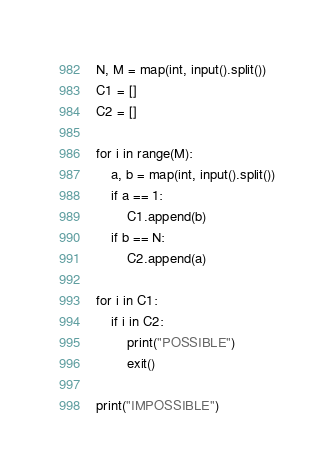<code> <loc_0><loc_0><loc_500><loc_500><_Python_>N, M = map(int, input().split())
C1 = []
C2 = []

for i in range(M):
    a, b = map(int, input().split())
    if a == 1:
        C1.append(b)
    if b == N:
        C2.append(a)

for i in C1:
    if i in C2:
        print("POSSIBLE")
        exit()

print("IMPOSSIBLE")
</code> 